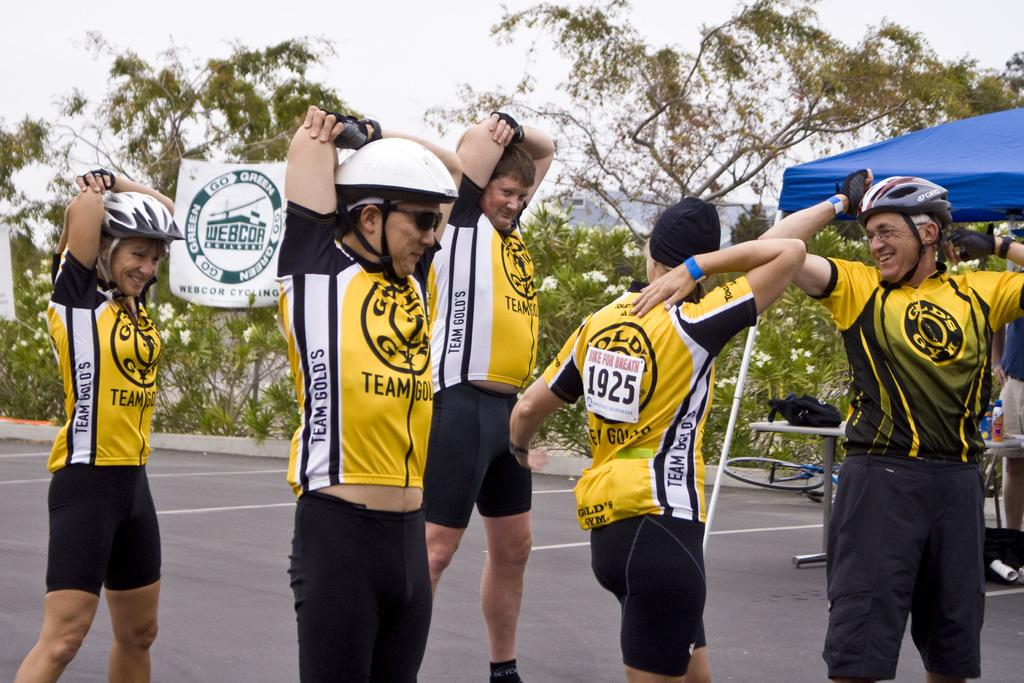<image>
Share a concise interpretation of the image provided. Cyclists wearing yellow and black uniforms and a square tag on the back with Bike for Breath on it. 